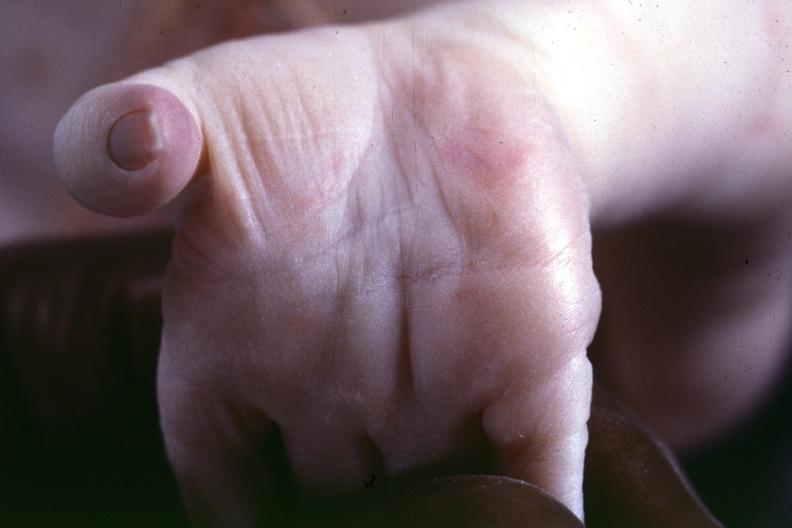does vasculature show source indicated?
Answer the question using a single word or phrase. No 